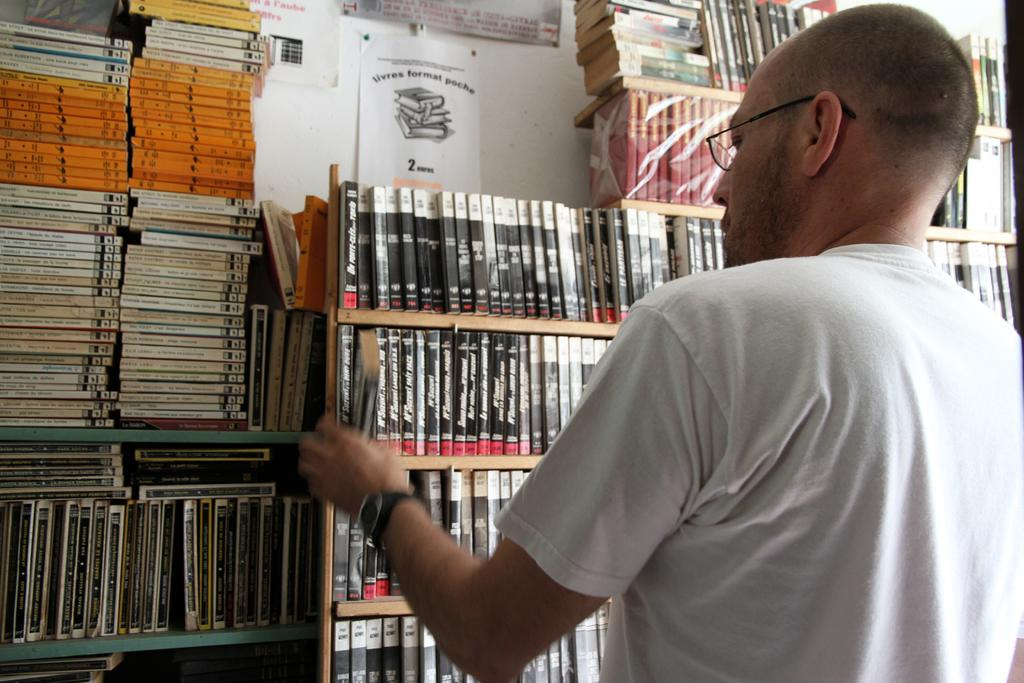<image>
Provide a brief description of the given image. A man is looking at the book and there is a sign about Iilvres format poche on top of the rack 